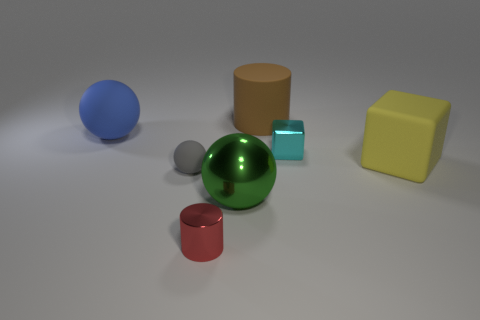How many gray objects are there?
Your answer should be compact. 1. There is a big thing to the left of the gray thing on the left side of the cylinder that is behind the large rubber cube; what color is it?
Ensure brevity in your answer.  Blue. Is the number of tiny cyan blocks less than the number of spheres?
Give a very brief answer. Yes. There is another shiny thing that is the same shape as the blue object; what color is it?
Give a very brief answer. Green. What is the color of the big ball that is made of the same material as the tiny sphere?
Your answer should be very brief. Blue. What number of red shiny objects have the same size as the cyan metal cube?
Keep it short and to the point. 1. What material is the small gray thing?
Provide a succinct answer. Rubber. Is the number of metallic cubes greater than the number of tiny things?
Offer a very short reply. No. Does the large green thing have the same shape as the cyan metal object?
Offer a very short reply. No. There is a small ball left of the small cylinder; does it have the same color as the tiny thing that is behind the gray rubber object?
Provide a succinct answer. No. 